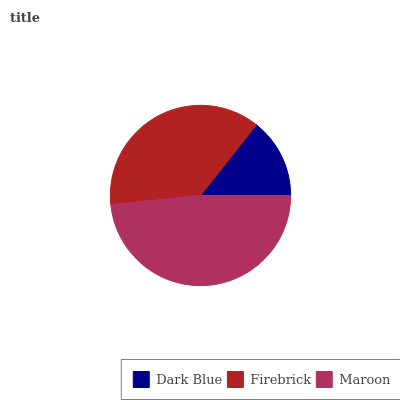Is Dark Blue the minimum?
Answer yes or no. Yes. Is Maroon the maximum?
Answer yes or no. Yes. Is Firebrick the minimum?
Answer yes or no. No. Is Firebrick the maximum?
Answer yes or no. No. Is Firebrick greater than Dark Blue?
Answer yes or no. Yes. Is Dark Blue less than Firebrick?
Answer yes or no. Yes. Is Dark Blue greater than Firebrick?
Answer yes or no. No. Is Firebrick less than Dark Blue?
Answer yes or no. No. Is Firebrick the high median?
Answer yes or no. Yes. Is Firebrick the low median?
Answer yes or no. Yes. Is Dark Blue the high median?
Answer yes or no. No. Is Dark Blue the low median?
Answer yes or no. No. 